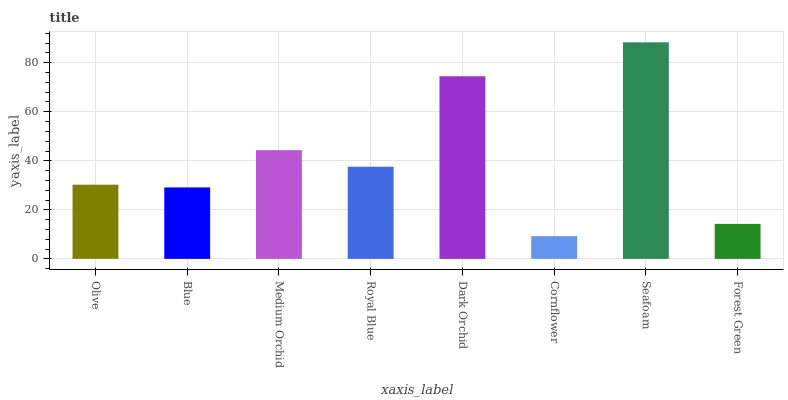Is Cornflower the minimum?
Answer yes or no. Yes. Is Seafoam the maximum?
Answer yes or no. Yes. Is Blue the minimum?
Answer yes or no. No. Is Blue the maximum?
Answer yes or no. No. Is Olive greater than Blue?
Answer yes or no. Yes. Is Blue less than Olive?
Answer yes or no. Yes. Is Blue greater than Olive?
Answer yes or no. No. Is Olive less than Blue?
Answer yes or no. No. Is Royal Blue the high median?
Answer yes or no. Yes. Is Olive the low median?
Answer yes or no. Yes. Is Dark Orchid the high median?
Answer yes or no. No. Is Cornflower the low median?
Answer yes or no. No. 